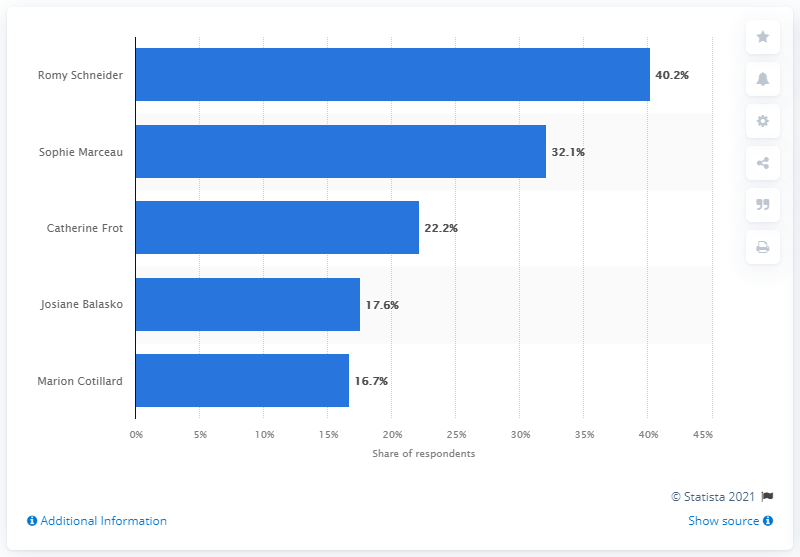Specify some key components in this picture. Romy Schneider was the most favored French actress among male viewers in 2015. 